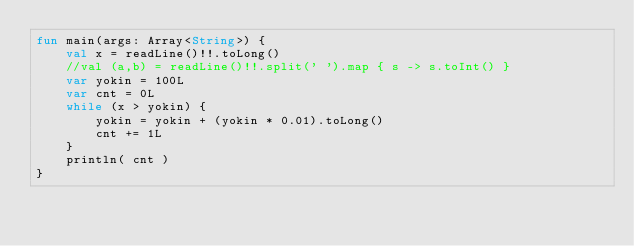<code> <loc_0><loc_0><loc_500><loc_500><_Kotlin_>fun main(args: Array<String>) {
    val x = readLine()!!.toLong()
    //val (a,b) = readLine()!!.split(' ').map { s -> s.toInt() }
    var yokin = 100L
    var cnt = 0L
    while (x > yokin) {
        yokin = yokin + (yokin * 0.01).toLong()
        cnt += 1L
    }
    println( cnt )
}</code> 